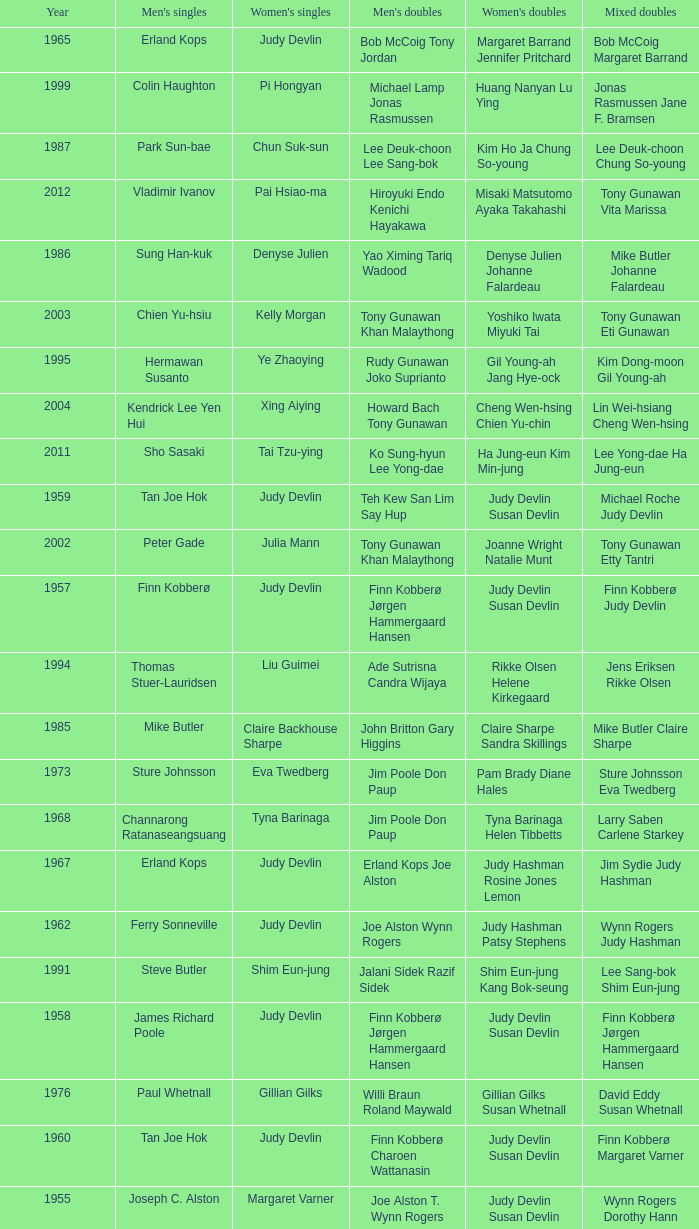Who were the men's doubles champions when the men's singles champion was muljadi? Ng Boon Bee Punch Gunalan. Could you help me parse every detail presented in this table? {'header': ['Year', "Men's singles", "Women's singles", "Men's doubles", "Women's doubles", 'Mixed doubles'], 'rows': [['1965', 'Erland Kops', 'Judy Devlin', 'Bob McCoig Tony Jordan', 'Margaret Barrand Jennifer Pritchard', 'Bob McCoig Margaret Barrand'], ['1999', 'Colin Haughton', 'Pi Hongyan', 'Michael Lamp Jonas Rasmussen', 'Huang Nanyan Lu Ying', 'Jonas Rasmussen Jane F. Bramsen'], ['1987', 'Park Sun-bae', 'Chun Suk-sun', 'Lee Deuk-choon Lee Sang-bok', 'Kim Ho Ja Chung So-young', 'Lee Deuk-choon Chung So-young'], ['2012', 'Vladimir Ivanov', 'Pai Hsiao-ma', 'Hiroyuki Endo Kenichi Hayakawa', 'Misaki Matsutomo Ayaka Takahashi', 'Tony Gunawan Vita Marissa'], ['1986', 'Sung Han-kuk', 'Denyse Julien', 'Yao Ximing Tariq Wadood', 'Denyse Julien Johanne Falardeau', 'Mike Butler Johanne Falardeau'], ['2003', 'Chien Yu-hsiu', 'Kelly Morgan', 'Tony Gunawan Khan Malaythong', 'Yoshiko Iwata Miyuki Tai', 'Tony Gunawan Eti Gunawan'], ['1995', 'Hermawan Susanto', 'Ye Zhaoying', 'Rudy Gunawan Joko Suprianto', 'Gil Young-ah Jang Hye-ock', 'Kim Dong-moon Gil Young-ah'], ['2004', 'Kendrick Lee Yen Hui', 'Xing Aiying', 'Howard Bach Tony Gunawan', 'Cheng Wen-hsing Chien Yu-chin', 'Lin Wei-hsiang Cheng Wen-hsing'], ['2011', 'Sho Sasaki', 'Tai Tzu-ying', 'Ko Sung-hyun Lee Yong-dae', 'Ha Jung-eun Kim Min-jung', 'Lee Yong-dae Ha Jung-eun'], ['1959', 'Tan Joe Hok', 'Judy Devlin', 'Teh Kew San Lim Say Hup', 'Judy Devlin Susan Devlin', 'Michael Roche Judy Devlin'], ['2002', 'Peter Gade', 'Julia Mann', 'Tony Gunawan Khan Malaythong', 'Joanne Wright Natalie Munt', 'Tony Gunawan Etty Tantri'], ['1957', 'Finn Kobberø', 'Judy Devlin', 'Finn Kobberø Jørgen Hammergaard Hansen', 'Judy Devlin Susan Devlin', 'Finn Kobberø Judy Devlin'], ['1994', 'Thomas Stuer-Lauridsen', 'Liu Guimei', 'Ade Sutrisna Candra Wijaya', 'Rikke Olsen Helene Kirkegaard', 'Jens Eriksen Rikke Olsen'], ['1985', 'Mike Butler', 'Claire Backhouse Sharpe', 'John Britton Gary Higgins', 'Claire Sharpe Sandra Skillings', 'Mike Butler Claire Sharpe'], ['1973', 'Sture Johnsson', 'Eva Twedberg', 'Jim Poole Don Paup', 'Pam Brady Diane Hales', 'Sture Johnsson Eva Twedberg'], ['1968', 'Channarong Ratanaseangsuang', 'Tyna Barinaga', 'Jim Poole Don Paup', 'Tyna Barinaga Helen Tibbetts', 'Larry Saben Carlene Starkey'], ['1967', 'Erland Kops', 'Judy Devlin', 'Erland Kops Joe Alston', 'Judy Hashman Rosine Jones Lemon', 'Jim Sydie Judy Hashman'], ['1962', 'Ferry Sonneville', 'Judy Devlin', 'Joe Alston Wynn Rogers', 'Judy Hashman Patsy Stephens', 'Wynn Rogers Judy Hashman'], ['1991', 'Steve Butler', 'Shim Eun-jung', 'Jalani Sidek Razif Sidek', 'Shim Eun-jung Kang Bok-seung', 'Lee Sang-bok Shim Eun-jung'], ['1958', 'James Richard Poole', 'Judy Devlin', 'Finn Kobberø Jørgen Hammergaard Hansen', 'Judy Devlin Susan Devlin', 'Finn Kobberø Jørgen Hammergaard Hansen'], ['1976', 'Paul Whetnall', 'Gillian Gilks', 'Willi Braun Roland Maywald', 'Gillian Gilks Susan Whetnall', 'David Eddy Susan Whetnall'], ['1960', 'Tan Joe Hok', 'Judy Devlin', 'Finn Kobberø Charoen Wattanasin', 'Judy Devlin Susan Devlin', 'Finn Kobberø Margaret Varner'], ['1955', 'Joseph C. Alston', 'Margaret Varner', 'Joe Alston T. Wynn Rogers', 'Judy Devlin Susan Devlin', 'Wynn Rogers Dorothy Hann'], ['1990', 'Fung Permadi', 'Denyse Julien', 'Ger Shin-Ming Yang Shih-Jeng', 'Denyse Julien Doris Piché', 'Tariq Wadood Traci Britton'], ['2013', 'Nguyen Tien Minh', 'Sapsiree Taerattanachai', 'Takeshi Kamura Keigo Sonoda', 'Bao Yixin Zhong Qianxin', 'Lee Chun Hei Chau Hoi Wah'], ['1977 1982', 'no competition', 'no competition', 'no competition', 'no competition', 'no competition'], ['1984', 'Xiong Guobao', 'Luo Yun', 'Chen Hongyong Zhang Qingwu', 'Yin Haichen Lu Yanahua', 'Wang Pengren Luo Yun'], ['1992', 'Poul-Erik Hoyer-Larsen', 'Lim Xiaoqing', 'Cheah Soon Kit Soo Beng Kiang', 'Lim Xiaoqing Christine Magnusson', 'Thomas Lund Pernille Dupont'], ['1996', 'Joko Suprianto', 'Mia Audina', 'Candra Wijaya Sigit Budiarto', 'Zelin Resiana Eliza Nathanael', 'Kim Dong-moon Chung So-young'], ['2010', 'Rajiv Ouseph', 'Zhu Lin', 'Fang Chieh-min Lee Sheng-mu', 'Cheng Wen-hsing Chien Yu-chin', 'Michael Fuchs Birgit Overzier'], ['1956', 'Finn Kobberø', 'Judy Devlin', 'Finn Kobberø Jørgen Hammergaard Hansen', 'Ethel Marshall Beatrice Massman', 'Finn Kobberø Judy Devlin'], ['1971', 'Muljadi', 'Noriko Takagi', 'Ng Boon Bee Punch Gunalan', 'Noriko Takagi Hiroe Yuki', 'Jim Poole Maryanne Breckell'], ['1954', 'Eddy B. Choong', 'Judy Devlin', 'Ooi Teik Hock Ong Poh Lim', 'Judy Devlin Susan Devlin', 'Joseph Cameron Alston Lois Alston'], ['1998', 'Fung Permadi', 'Tang Yeping', 'Horng Shin-Jeng Lee Wei-Jen', 'Elinor Middlemiss Kirsteen McEwan', 'Kenny Middlemiss Elinor Middlemiss'], ['2000', 'Ardy Wiranata', 'Choi Ma-re', 'Graham Hurrell James Anderson', 'Gail Emms Joanne Wright', 'Jonas Rasmussen Jane F. Bramsen'], ['2008', 'Andrew Dabeka', 'Lili Zhou', 'Howard Bach Khan Malaythong', 'Chang Li-Ying Hung Shih-Chieh', 'Halim Haryanto Peng Yun'], ['2001', 'Lee Hyun-il', 'Ra Kyung-min', 'Kang Kyung-jin Park Young-duk', 'Kim Kyeung-ran Ra Kyung-min', 'Mathias Boe Majken Vange'], ['2007', 'Lee Tsuen Seng', 'Jun Jae-youn', 'Tadashi Ohtsuka Keita Masuda', 'Miyuki Maeda Satoko Suetsuna', 'Keita Masuda Miyuki Maeda'], ['2009', 'Taufik Hidayat', 'Anna Rice', 'Howard Bach Tony Gunawan', 'Ruilin Huang Xuelian Jiang', 'Howard Bach Eva Lee'], ['1970', 'Junji Honma', 'Etsuko Takenaka', 'Junji Honma Ippei Kojima', 'Etsuko Takenaka Machiko Aizawa', 'Paul Whetnall Margaret Boxall'], ['1963', 'Erland Kops', 'Judy Devlin', 'Erland Kops Bob McCoig', 'Judy Hashman Susan Peard', 'Sangob Rattanusorn Margaret Barrand'], ['1983', 'Mike Butler', 'Sherrie Liu', 'John Britton Gary Higgins', 'Claire Backhouse Johanne Falardeau', 'Mike Butler Claire Backhouse'], ['1988', 'Sze Yu', 'Lee Myeong-hee', 'Christian Hadinata Lius Pongoh', 'Kim Ho Ja Chung So-young', 'Christian Hadinata Ivana Lie'], ['1969', 'Rudy Hartono', 'Minarni', 'Ng Boon Bee Punch Gunalan', 'Minarni Retno Kustijah', 'Erland Kops Pernille Molgaard Hansen'], ['1993', 'Marleve Mainaky', 'Lim Xiaoqing', 'Thomas Lund Jon Holst-Christensen', 'Gil Young-ah Chung So-young', 'Thomas Lund Catrine Bengtsson'], ['1966', 'Tan Aik Huang', 'Judy Devlin', 'Ng Boon Bee Tan Yee Khan', 'Judy Hashman Susan Peard', 'Wayne MacDonnell Tyna Barinaga'], ['2006', 'Yousuke Nakanishi', 'Ella Karachkova', 'Halim Haryanto Tony Gunawan', 'Nina Vislova Valeria Sorokina', 'Sergey Ivlev Nina Vislova'], ['1974 1975', 'no competition', 'no competition', 'no competition', 'no competition', 'no competition'], ['1961', 'James Richard Poole', 'Judy Devlin', 'Joe Alston Wynn Rogers', 'Judy Devlin Hashman Susan Devlin Peard', 'Wynn Rogers Judy Devlin Hashman'], ['1972', 'Sture Johnsson', 'Eva Twedberg', 'Derek Talbot Elliot Stuart', 'Anne Berglund Pernille Kaagaard', 'Flemming Delfs Pernille Kaagaard'], ['1989', 'no competition', 'no competition', 'no competition', 'no competition', 'no competition'], ['2005', 'Hsieh Yu-hsing', 'Lili Zhou', 'Howard Bach Tony Gunawan', 'Peng Yun Johanna Lee', 'Khan Malaythong Mesinee Mangkalakiri'], ['1964', 'Channarong Ratanaseangsuang', "Dorothy O'Neil", 'Joe Alston Wynn Rogers', 'Tyna Barinaga Caroline Jensen', 'Channarong Ratanaseangsuang Margaret Barrand'], ['1997', 'Poul-Erik Hoyer-Larsen', 'Camilla Martin', 'Ha Tae-kwon Kim Dong-moon', 'Qin Yiyuan Tang Yongshu', 'Kim Dong Moon Ra Kyung-min']]} 